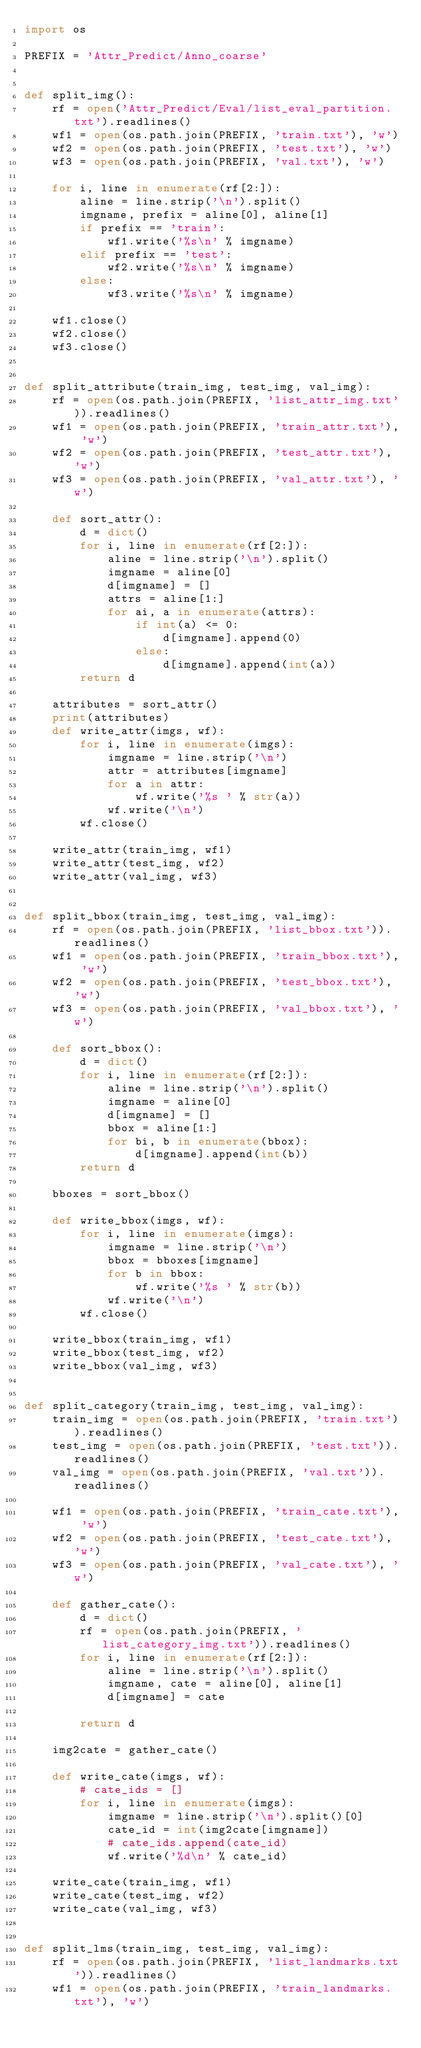Convert code to text. <code><loc_0><loc_0><loc_500><loc_500><_Python_>import os

PREFIX = 'Attr_Predict/Anno_coarse'


def split_img():
    rf = open('Attr_Predict/Eval/list_eval_partition.txt').readlines()
    wf1 = open(os.path.join(PREFIX, 'train.txt'), 'w')
    wf2 = open(os.path.join(PREFIX, 'test.txt'), 'w')
    wf3 = open(os.path.join(PREFIX, 'val.txt'), 'w')

    for i, line in enumerate(rf[2:]):
        aline = line.strip('\n').split()
        imgname, prefix = aline[0], aline[1]
        if prefix == 'train':
            wf1.write('%s\n' % imgname)
        elif prefix == 'test':
            wf2.write('%s\n' % imgname)
        else:
            wf3.write('%s\n' % imgname)

    wf1.close()
    wf2.close()
    wf3.close()


def split_attribute(train_img, test_img, val_img):
    rf = open(os.path.join(PREFIX, 'list_attr_img.txt')).readlines()
    wf1 = open(os.path.join(PREFIX, 'train_attr.txt'), 'w')
    wf2 = open(os.path.join(PREFIX, 'test_attr.txt'), 'w')
    wf3 = open(os.path.join(PREFIX, 'val_attr.txt'), 'w')

    def sort_attr():
        d = dict()
        for i, line in enumerate(rf[2:]):
            aline = line.strip('\n').split()
            imgname = aline[0]
            d[imgname] = []
            attrs = aline[1:]
            for ai, a in enumerate(attrs):
                if int(a) <= 0:
                    d[imgname].append(0)
                else:
                    d[imgname].append(int(a))
        return d

    attributes = sort_attr()
    print(attributes)
    def write_attr(imgs, wf):
        for i, line in enumerate(imgs):
            imgname = line.strip('\n')
            attr = attributes[imgname]
            for a in attr:
                wf.write('%s ' % str(a))
            wf.write('\n')
        wf.close()

    write_attr(train_img, wf1)
    write_attr(test_img, wf2)
    write_attr(val_img, wf3)


def split_bbox(train_img, test_img, val_img):
    rf = open(os.path.join(PREFIX, 'list_bbox.txt')).readlines()
    wf1 = open(os.path.join(PREFIX, 'train_bbox.txt'), 'w')
    wf2 = open(os.path.join(PREFIX, 'test_bbox.txt'), 'w')
    wf3 = open(os.path.join(PREFIX, 'val_bbox.txt'), 'w')

    def sort_bbox():
        d = dict()
        for i, line in enumerate(rf[2:]):
            aline = line.strip('\n').split()
            imgname = aline[0]
            d[imgname] = []
            bbox = aline[1:]
            for bi, b in enumerate(bbox):
                d[imgname].append(int(b))
        return d

    bboxes = sort_bbox()

    def write_bbox(imgs, wf):
        for i, line in enumerate(imgs):
            imgname = line.strip('\n')
            bbox = bboxes[imgname]
            for b in bbox:
                wf.write('%s ' % str(b))
            wf.write('\n')
        wf.close()

    write_bbox(train_img, wf1)
    write_bbox(test_img, wf2)
    write_bbox(val_img, wf3)


def split_category(train_img, test_img, val_img):
    train_img = open(os.path.join(PREFIX, 'train.txt')).readlines()
    test_img = open(os.path.join(PREFIX, 'test.txt')).readlines()
    val_img = open(os.path.join(PREFIX, 'val.txt')).readlines()

    wf1 = open(os.path.join(PREFIX, 'train_cate.txt'), 'w')
    wf2 = open(os.path.join(PREFIX, 'test_cate.txt'), 'w')
    wf3 = open(os.path.join(PREFIX, 'val_cate.txt'), 'w')

    def gather_cate():
        d = dict()
        rf = open(os.path.join(PREFIX, 'list_category_img.txt')).readlines()
        for i, line in enumerate(rf[2:]):
            aline = line.strip('\n').split()
            imgname, cate = aline[0], aline[1]
            d[imgname] = cate

        return d

    img2cate = gather_cate()

    def write_cate(imgs, wf):
        # cate_ids = []
        for i, line in enumerate(imgs):
            imgname = line.strip('\n').split()[0]
            cate_id = int(img2cate[imgname])
            # cate_ids.append(cate_id)
            wf.write('%d\n' % cate_id)

    write_cate(train_img, wf1)
    write_cate(test_img, wf2)
    write_cate(val_img, wf3)


def split_lms(train_img, test_img, val_img):
    rf = open(os.path.join(PREFIX, 'list_landmarks.txt')).readlines()
    wf1 = open(os.path.join(PREFIX, 'train_landmarks.txt'), 'w')</code> 